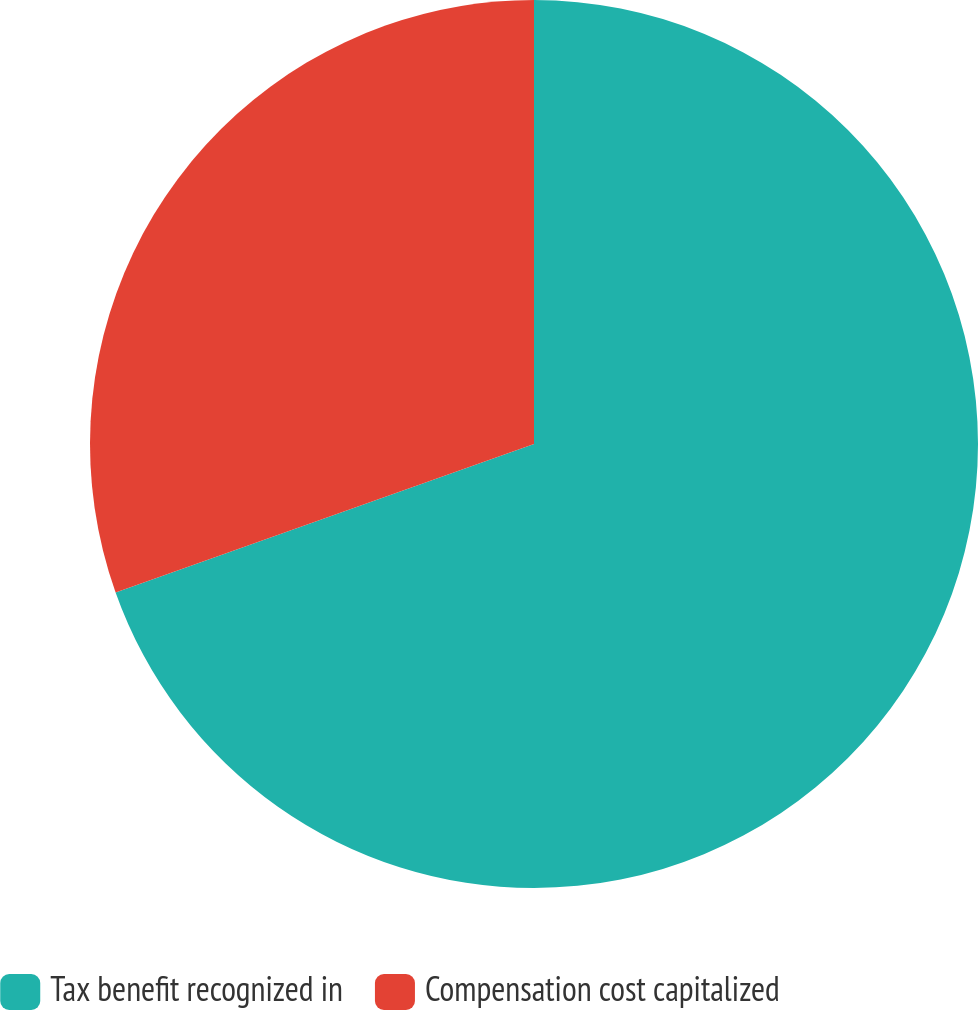<chart> <loc_0><loc_0><loc_500><loc_500><pie_chart><fcel>Tax benefit recognized in<fcel>Compensation cost capitalized<nl><fcel>69.57%<fcel>30.43%<nl></chart> 